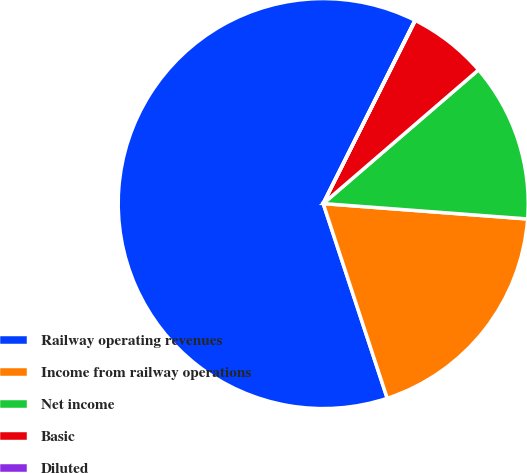Convert chart. <chart><loc_0><loc_0><loc_500><loc_500><pie_chart><fcel>Railway operating revenues<fcel>Income from railway operations<fcel>Net income<fcel>Basic<fcel>Diluted<nl><fcel>62.44%<fcel>18.75%<fcel>12.51%<fcel>6.27%<fcel>0.03%<nl></chart> 